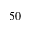Convert formula to latex. <formula><loc_0><loc_0><loc_500><loc_500>5 0</formula> 